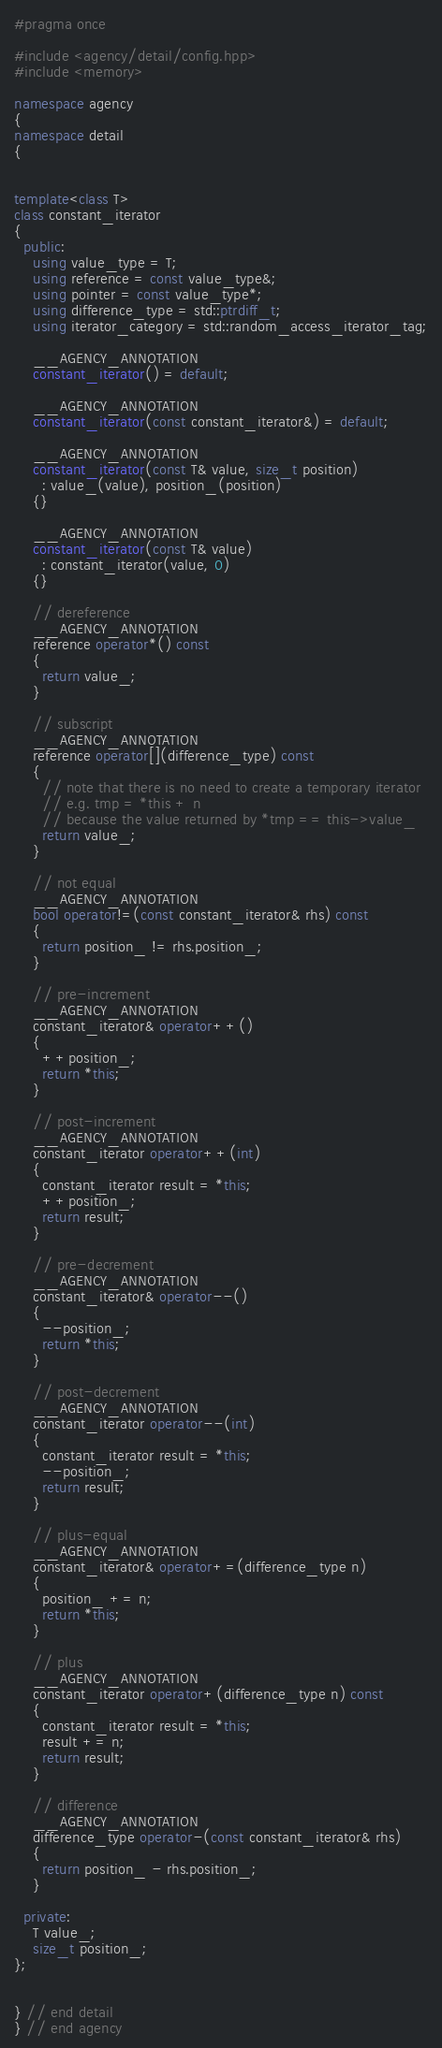<code> <loc_0><loc_0><loc_500><loc_500><_C++_>#pragma once

#include <agency/detail/config.hpp>
#include <memory>

namespace agency
{
namespace detail
{


template<class T>
class constant_iterator
{
  public:
    using value_type = T;
    using reference = const value_type&;
    using pointer = const value_type*;
    using difference_type = std::ptrdiff_t;
    using iterator_category = std::random_access_iterator_tag;

    __AGENCY_ANNOTATION
    constant_iterator() = default;

    __AGENCY_ANNOTATION
    constant_iterator(const constant_iterator&) = default;

    __AGENCY_ANNOTATION
    constant_iterator(const T& value, size_t position)
      : value_(value), position_(position)
    {}

    __AGENCY_ANNOTATION
    constant_iterator(const T& value)
      : constant_iterator(value, 0)
    {}

    // dereference
    __AGENCY_ANNOTATION
    reference operator*() const
    {
      return value_;
    }

    // subscript
    __AGENCY_ANNOTATION
    reference operator[](difference_type) const
    {
      // note that there is no need to create a temporary iterator
      // e.g. tmp = *this + n
      // because the value returned by *tmp == this->value_
      return value_;
    }

    // not equal
    __AGENCY_ANNOTATION
    bool operator!=(const constant_iterator& rhs) const
    {
      return position_ != rhs.position_;
    }

    // pre-increment
    __AGENCY_ANNOTATION
    constant_iterator& operator++()
    {
      ++position_;
      return *this;
    }

    // post-increment
    __AGENCY_ANNOTATION
    constant_iterator operator++(int)
    {
      constant_iterator result = *this;
      ++position_;
      return result;
    }

    // pre-decrement
    __AGENCY_ANNOTATION
    constant_iterator& operator--()
    {
      --position_;
      return *this;
    }

    // post-decrement
    __AGENCY_ANNOTATION
    constant_iterator operator--(int)
    {
      constant_iterator result = *this;
      --position_;
      return result;
    }

    // plus-equal
    __AGENCY_ANNOTATION
    constant_iterator& operator+=(difference_type n)
    {
      position_ += n;
      return *this;
    }

    // plus
    __AGENCY_ANNOTATION
    constant_iterator operator+(difference_type n) const
    {
      constant_iterator result = *this;
      result += n;
      return result;
    }

    // difference
    __AGENCY_ANNOTATION
    difference_type operator-(const constant_iterator& rhs)
    {
      return position_ - rhs.position_;
    }

  private:
    T value_;
    size_t position_;
};


} // end detail
} // end agency

</code> 